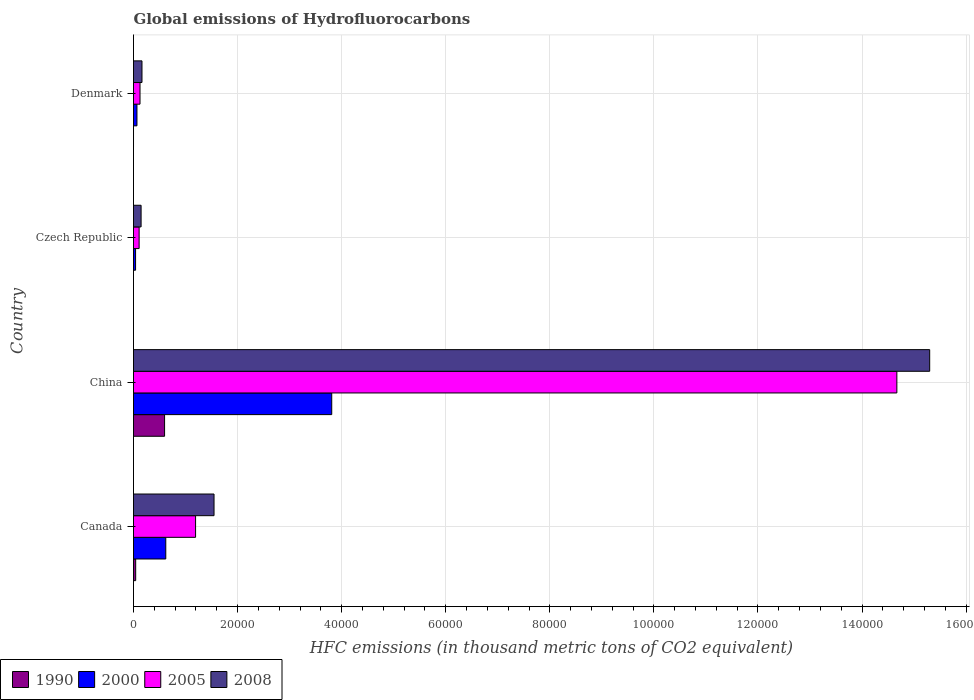How many groups of bars are there?
Offer a very short reply. 4. Are the number of bars on each tick of the Y-axis equal?
Offer a terse response. Yes. What is the global emissions of Hydrofluorocarbons in 2005 in China?
Keep it short and to the point. 1.47e+05. Across all countries, what is the maximum global emissions of Hydrofluorocarbons in 2008?
Make the answer very short. 1.53e+05. Across all countries, what is the minimum global emissions of Hydrofluorocarbons in 2000?
Give a very brief answer. 399.5. In which country was the global emissions of Hydrofluorocarbons in 2008 maximum?
Ensure brevity in your answer.  China. In which country was the global emissions of Hydrofluorocarbons in 2008 minimum?
Offer a very short reply. Czech Republic. What is the total global emissions of Hydrofluorocarbons in 2000 in the graph?
Provide a short and direct response. 4.54e+04. What is the difference between the global emissions of Hydrofluorocarbons in 1990 in Czech Republic and that in Denmark?
Provide a succinct answer. -0.2. What is the difference between the global emissions of Hydrofluorocarbons in 2005 in Denmark and the global emissions of Hydrofluorocarbons in 2000 in Canada?
Your response must be concise. -4953.3. What is the average global emissions of Hydrofluorocarbons in 2008 per country?
Keep it short and to the point. 4.29e+04. What is the difference between the global emissions of Hydrofluorocarbons in 2005 and global emissions of Hydrofluorocarbons in 2008 in China?
Your answer should be compact. -6309. In how many countries, is the global emissions of Hydrofluorocarbons in 2000 greater than 68000 thousand metric tons?
Your response must be concise. 0. What is the ratio of the global emissions of Hydrofluorocarbons in 2008 in China to that in Czech Republic?
Ensure brevity in your answer.  104.87. What is the difference between the highest and the second highest global emissions of Hydrofluorocarbons in 2005?
Offer a very short reply. 1.35e+05. What is the difference between the highest and the lowest global emissions of Hydrofluorocarbons in 1990?
Provide a succinct answer. 5970. Is the sum of the global emissions of Hydrofluorocarbons in 2005 in Czech Republic and Denmark greater than the maximum global emissions of Hydrofluorocarbons in 2008 across all countries?
Keep it short and to the point. No. Is it the case that in every country, the sum of the global emissions of Hydrofluorocarbons in 2000 and global emissions of Hydrofluorocarbons in 2008 is greater than the sum of global emissions of Hydrofluorocarbons in 1990 and global emissions of Hydrofluorocarbons in 2005?
Ensure brevity in your answer.  No. What does the 2nd bar from the top in China represents?
Your answer should be very brief. 2005. Are all the bars in the graph horizontal?
Offer a very short reply. Yes. What is the difference between two consecutive major ticks on the X-axis?
Give a very brief answer. 2.00e+04. Are the values on the major ticks of X-axis written in scientific E-notation?
Make the answer very short. No. Does the graph contain any zero values?
Keep it short and to the point. No. Where does the legend appear in the graph?
Offer a terse response. Bottom left. How are the legend labels stacked?
Offer a very short reply. Horizontal. What is the title of the graph?
Ensure brevity in your answer.  Global emissions of Hydrofluorocarbons. Does "1975" appear as one of the legend labels in the graph?
Keep it short and to the point. No. What is the label or title of the X-axis?
Your answer should be compact. HFC emissions (in thousand metric tons of CO2 equivalent). What is the label or title of the Y-axis?
Your response must be concise. Country. What is the HFC emissions (in thousand metric tons of CO2 equivalent) in 1990 in Canada?
Your answer should be very brief. 418.5. What is the HFC emissions (in thousand metric tons of CO2 equivalent) of 2000 in Canada?
Give a very brief answer. 6202.8. What is the HFC emissions (in thousand metric tons of CO2 equivalent) in 2005 in Canada?
Offer a terse response. 1.19e+04. What is the HFC emissions (in thousand metric tons of CO2 equivalent) in 2008 in Canada?
Offer a very short reply. 1.55e+04. What is the HFC emissions (in thousand metric tons of CO2 equivalent) of 1990 in China?
Give a very brief answer. 5970.1. What is the HFC emissions (in thousand metric tons of CO2 equivalent) in 2000 in China?
Make the answer very short. 3.81e+04. What is the HFC emissions (in thousand metric tons of CO2 equivalent) of 2005 in China?
Your response must be concise. 1.47e+05. What is the HFC emissions (in thousand metric tons of CO2 equivalent) in 2008 in China?
Make the answer very short. 1.53e+05. What is the HFC emissions (in thousand metric tons of CO2 equivalent) of 2000 in Czech Republic?
Provide a succinct answer. 399.5. What is the HFC emissions (in thousand metric tons of CO2 equivalent) in 2005 in Czech Republic?
Your answer should be very brief. 1078.7. What is the HFC emissions (in thousand metric tons of CO2 equivalent) in 2008 in Czech Republic?
Provide a short and direct response. 1459. What is the HFC emissions (in thousand metric tons of CO2 equivalent) of 2000 in Denmark?
Make the answer very short. 662.2. What is the HFC emissions (in thousand metric tons of CO2 equivalent) in 2005 in Denmark?
Provide a succinct answer. 1249.5. What is the HFC emissions (in thousand metric tons of CO2 equivalent) in 2008 in Denmark?
Give a very brief answer. 1629.6. Across all countries, what is the maximum HFC emissions (in thousand metric tons of CO2 equivalent) in 1990?
Offer a very short reply. 5970.1. Across all countries, what is the maximum HFC emissions (in thousand metric tons of CO2 equivalent) of 2000?
Provide a succinct answer. 3.81e+04. Across all countries, what is the maximum HFC emissions (in thousand metric tons of CO2 equivalent) in 2005?
Provide a succinct answer. 1.47e+05. Across all countries, what is the maximum HFC emissions (in thousand metric tons of CO2 equivalent) of 2008?
Provide a succinct answer. 1.53e+05. Across all countries, what is the minimum HFC emissions (in thousand metric tons of CO2 equivalent) in 1990?
Offer a very short reply. 0.1. Across all countries, what is the minimum HFC emissions (in thousand metric tons of CO2 equivalent) of 2000?
Keep it short and to the point. 399.5. Across all countries, what is the minimum HFC emissions (in thousand metric tons of CO2 equivalent) in 2005?
Give a very brief answer. 1078.7. Across all countries, what is the minimum HFC emissions (in thousand metric tons of CO2 equivalent) in 2008?
Offer a very short reply. 1459. What is the total HFC emissions (in thousand metric tons of CO2 equivalent) in 1990 in the graph?
Ensure brevity in your answer.  6389. What is the total HFC emissions (in thousand metric tons of CO2 equivalent) in 2000 in the graph?
Offer a terse response. 4.54e+04. What is the total HFC emissions (in thousand metric tons of CO2 equivalent) in 2005 in the graph?
Give a very brief answer. 1.61e+05. What is the total HFC emissions (in thousand metric tons of CO2 equivalent) of 2008 in the graph?
Offer a very short reply. 1.72e+05. What is the difference between the HFC emissions (in thousand metric tons of CO2 equivalent) of 1990 in Canada and that in China?
Provide a succinct answer. -5551.6. What is the difference between the HFC emissions (in thousand metric tons of CO2 equivalent) in 2000 in Canada and that in China?
Offer a terse response. -3.19e+04. What is the difference between the HFC emissions (in thousand metric tons of CO2 equivalent) of 2005 in Canada and that in China?
Give a very brief answer. -1.35e+05. What is the difference between the HFC emissions (in thousand metric tons of CO2 equivalent) in 2008 in Canada and that in China?
Your answer should be very brief. -1.38e+05. What is the difference between the HFC emissions (in thousand metric tons of CO2 equivalent) in 1990 in Canada and that in Czech Republic?
Your response must be concise. 418.4. What is the difference between the HFC emissions (in thousand metric tons of CO2 equivalent) of 2000 in Canada and that in Czech Republic?
Your answer should be compact. 5803.3. What is the difference between the HFC emissions (in thousand metric tons of CO2 equivalent) of 2005 in Canada and that in Czech Republic?
Offer a terse response. 1.08e+04. What is the difference between the HFC emissions (in thousand metric tons of CO2 equivalent) of 2008 in Canada and that in Czech Republic?
Your response must be concise. 1.40e+04. What is the difference between the HFC emissions (in thousand metric tons of CO2 equivalent) of 1990 in Canada and that in Denmark?
Keep it short and to the point. 418.2. What is the difference between the HFC emissions (in thousand metric tons of CO2 equivalent) of 2000 in Canada and that in Denmark?
Make the answer very short. 5540.6. What is the difference between the HFC emissions (in thousand metric tons of CO2 equivalent) of 2005 in Canada and that in Denmark?
Ensure brevity in your answer.  1.07e+04. What is the difference between the HFC emissions (in thousand metric tons of CO2 equivalent) in 2008 in Canada and that in Denmark?
Give a very brief answer. 1.38e+04. What is the difference between the HFC emissions (in thousand metric tons of CO2 equivalent) of 1990 in China and that in Czech Republic?
Make the answer very short. 5970. What is the difference between the HFC emissions (in thousand metric tons of CO2 equivalent) of 2000 in China and that in Czech Republic?
Your answer should be very brief. 3.77e+04. What is the difference between the HFC emissions (in thousand metric tons of CO2 equivalent) of 2005 in China and that in Czech Republic?
Your response must be concise. 1.46e+05. What is the difference between the HFC emissions (in thousand metric tons of CO2 equivalent) of 2008 in China and that in Czech Republic?
Keep it short and to the point. 1.52e+05. What is the difference between the HFC emissions (in thousand metric tons of CO2 equivalent) of 1990 in China and that in Denmark?
Give a very brief answer. 5969.8. What is the difference between the HFC emissions (in thousand metric tons of CO2 equivalent) of 2000 in China and that in Denmark?
Keep it short and to the point. 3.74e+04. What is the difference between the HFC emissions (in thousand metric tons of CO2 equivalent) of 2005 in China and that in Denmark?
Ensure brevity in your answer.  1.45e+05. What is the difference between the HFC emissions (in thousand metric tons of CO2 equivalent) in 2008 in China and that in Denmark?
Your response must be concise. 1.51e+05. What is the difference between the HFC emissions (in thousand metric tons of CO2 equivalent) of 1990 in Czech Republic and that in Denmark?
Your answer should be compact. -0.2. What is the difference between the HFC emissions (in thousand metric tons of CO2 equivalent) in 2000 in Czech Republic and that in Denmark?
Your answer should be very brief. -262.7. What is the difference between the HFC emissions (in thousand metric tons of CO2 equivalent) in 2005 in Czech Republic and that in Denmark?
Give a very brief answer. -170.8. What is the difference between the HFC emissions (in thousand metric tons of CO2 equivalent) in 2008 in Czech Republic and that in Denmark?
Your answer should be very brief. -170.6. What is the difference between the HFC emissions (in thousand metric tons of CO2 equivalent) of 1990 in Canada and the HFC emissions (in thousand metric tons of CO2 equivalent) of 2000 in China?
Make the answer very short. -3.77e+04. What is the difference between the HFC emissions (in thousand metric tons of CO2 equivalent) in 1990 in Canada and the HFC emissions (in thousand metric tons of CO2 equivalent) in 2005 in China?
Your answer should be very brief. -1.46e+05. What is the difference between the HFC emissions (in thousand metric tons of CO2 equivalent) of 1990 in Canada and the HFC emissions (in thousand metric tons of CO2 equivalent) of 2008 in China?
Provide a succinct answer. -1.53e+05. What is the difference between the HFC emissions (in thousand metric tons of CO2 equivalent) in 2000 in Canada and the HFC emissions (in thousand metric tons of CO2 equivalent) in 2005 in China?
Your response must be concise. -1.40e+05. What is the difference between the HFC emissions (in thousand metric tons of CO2 equivalent) in 2000 in Canada and the HFC emissions (in thousand metric tons of CO2 equivalent) in 2008 in China?
Ensure brevity in your answer.  -1.47e+05. What is the difference between the HFC emissions (in thousand metric tons of CO2 equivalent) of 2005 in Canada and the HFC emissions (in thousand metric tons of CO2 equivalent) of 2008 in China?
Provide a short and direct response. -1.41e+05. What is the difference between the HFC emissions (in thousand metric tons of CO2 equivalent) of 1990 in Canada and the HFC emissions (in thousand metric tons of CO2 equivalent) of 2005 in Czech Republic?
Make the answer very short. -660.2. What is the difference between the HFC emissions (in thousand metric tons of CO2 equivalent) in 1990 in Canada and the HFC emissions (in thousand metric tons of CO2 equivalent) in 2008 in Czech Republic?
Provide a short and direct response. -1040.5. What is the difference between the HFC emissions (in thousand metric tons of CO2 equivalent) of 2000 in Canada and the HFC emissions (in thousand metric tons of CO2 equivalent) of 2005 in Czech Republic?
Your answer should be compact. 5124.1. What is the difference between the HFC emissions (in thousand metric tons of CO2 equivalent) of 2000 in Canada and the HFC emissions (in thousand metric tons of CO2 equivalent) of 2008 in Czech Republic?
Ensure brevity in your answer.  4743.8. What is the difference between the HFC emissions (in thousand metric tons of CO2 equivalent) in 2005 in Canada and the HFC emissions (in thousand metric tons of CO2 equivalent) in 2008 in Czech Republic?
Provide a succinct answer. 1.05e+04. What is the difference between the HFC emissions (in thousand metric tons of CO2 equivalent) in 1990 in Canada and the HFC emissions (in thousand metric tons of CO2 equivalent) in 2000 in Denmark?
Provide a short and direct response. -243.7. What is the difference between the HFC emissions (in thousand metric tons of CO2 equivalent) of 1990 in Canada and the HFC emissions (in thousand metric tons of CO2 equivalent) of 2005 in Denmark?
Your answer should be very brief. -831. What is the difference between the HFC emissions (in thousand metric tons of CO2 equivalent) of 1990 in Canada and the HFC emissions (in thousand metric tons of CO2 equivalent) of 2008 in Denmark?
Your answer should be compact. -1211.1. What is the difference between the HFC emissions (in thousand metric tons of CO2 equivalent) of 2000 in Canada and the HFC emissions (in thousand metric tons of CO2 equivalent) of 2005 in Denmark?
Your answer should be very brief. 4953.3. What is the difference between the HFC emissions (in thousand metric tons of CO2 equivalent) in 2000 in Canada and the HFC emissions (in thousand metric tons of CO2 equivalent) in 2008 in Denmark?
Provide a succinct answer. 4573.2. What is the difference between the HFC emissions (in thousand metric tons of CO2 equivalent) of 2005 in Canada and the HFC emissions (in thousand metric tons of CO2 equivalent) of 2008 in Denmark?
Offer a very short reply. 1.03e+04. What is the difference between the HFC emissions (in thousand metric tons of CO2 equivalent) of 1990 in China and the HFC emissions (in thousand metric tons of CO2 equivalent) of 2000 in Czech Republic?
Offer a very short reply. 5570.6. What is the difference between the HFC emissions (in thousand metric tons of CO2 equivalent) in 1990 in China and the HFC emissions (in thousand metric tons of CO2 equivalent) in 2005 in Czech Republic?
Make the answer very short. 4891.4. What is the difference between the HFC emissions (in thousand metric tons of CO2 equivalent) of 1990 in China and the HFC emissions (in thousand metric tons of CO2 equivalent) of 2008 in Czech Republic?
Offer a very short reply. 4511.1. What is the difference between the HFC emissions (in thousand metric tons of CO2 equivalent) of 2000 in China and the HFC emissions (in thousand metric tons of CO2 equivalent) of 2005 in Czech Republic?
Ensure brevity in your answer.  3.70e+04. What is the difference between the HFC emissions (in thousand metric tons of CO2 equivalent) in 2000 in China and the HFC emissions (in thousand metric tons of CO2 equivalent) in 2008 in Czech Republic?
Offer a terse response. 3.66e+04. What is the difference between the HFC emissions (in thousand metric tons of CO2 equivalent) in 2005 in China and the HFC emissions (in thousand metric tons of CO2 equivalent) in 2008 in Czech Republic?
Provide a succinct answer. 1.45e+05. What is the difference between the HFC emissions (in thousand metric tons of CO2 equivalent) in 1990 in China and the HFC emissions (in thousand metric tons of CO2 equivalent) in 2000 in Denmark?
Make the answer very short. 5307.9. What is the difference between the HFC emissions (in thousand metric tons of CO2 equivalent) in 1990 in China and the HFC emissions (in thousand metric tons of CO2 equivalent) in 2005 in Denmark?
Provide a short and direct response. 4720.6. What is the difference between the HFC emissions (in thousand metric tons of CO2 equivalent) in 1990 in China and the HFC emissions (in thousand metric tons of CO2 equivalent) in 2008 in Denmark?
Offer a terse response. 4340.5. What is the difference between the HFC emissions (in thousand metric tons of CO2 equivalent) of 2000 in China and the HFC emissions (in thousand metric tons of CO2 equivalent) of 2005 in Denmark?
Offer a terse response. 3.68e+04. What is the difference between the HFC emissions (in thousand metric tons of CO2 equivalent) of 2000 in China and the HFC emissions (in thousand metric tons of CO2 equivalent) of 2008 in Denmark?
Make the answer very short. 3.65e+04. What is the difference between the HFC emissions (in thousand metric tons of CO2 equivalent) in 2005 in China and the HFC emissions (in thousand metric tons of CO2 equivalent) in 2008 in Denmark?
Provide a short and direct response. 1.45e+05. What is the difference between the HFC emissions (in thousand metric tons of CO2 equivalent) of 1990 in Czech Republic and the HFC emissions (in thousand metric tons of CO2 equivalent) of 2000 in Denmark?
Offer a terse response. -662.1. What is the difference between the HFC emissions (in thousand metric tons of CO2 equivalent) of 1990 in Czech Republic and the HFC emissions (in thousand metric tons of CO2 equivalent) of 2005 in Denmark?
Provide a succinct answer. -1249.4. What is the difference between the HFC emissions (in thousand metric tons of CO2 equivalent) in 1990 in Czech Republic and the HFC emissions (in thousand metric tons of CO2 equivalent) in 2008 in Denmark?
Offer a very short reply. -1629.5. What is the difference between the HFC emissions (in thousand metric tons of CO2 equivalent) in 2000 in Czech Republic and the HFC emissions (in thousand metric tons of CO2 equivalent) in 2005 in Denmark?
Keep it short and to the point. -850. What is the difference between the HFC emissions (in thousand metric tons of CO2 equivalent) in 2000 in Czech Republic and the HFC emissions (in thousand metric tons of CO2 equivalent) in 2008 in Denmark?
Give a very brief answer. -1230.1. What is the difference between the HFC emissions (in thousand metric tons of CO2 equivalent) in 2005 in Czech Republic and the HFC emissions (in thousand metric tons of CO2 equivalent) in 2008 in Denmark?
Give a very brief answer. -550.9. What is the average HFC emissions (in thousand metric tons of CO2 equivalent) of 1990 per country?
Your response must be concise. 1597.25. What is the average HFC emissions (in thousand metric tons of CO2 equivalent) in 2000 per country?
Ensure brevity in your answer.  1.13e+04. What is the average HFC emissions (in thousand metric tons of CO2 equivalent) in 2005 per country?
Your answer should be compact. 4.02e+04. What is the average HFC emissions (in thousand metric tons of CO2 equivalent) in 2008 per country?
Give a very brief answer. 4.29e+04. What is the difference between the HFC emissions (in thousand metric tons of CO2 equivalent) in 1990 and HFC emissions (in thousand metric tons of CO2 equivalent) in 2000 in Canada?
Ensure brevity in your answer.  -5784.3. What is the difference between the HFC emissions (in thousand metric tons of CO2 equivalent) of 1990 and HFC emissions (in thousand metric tons of CO2 equivalent) of 2005 in Canada?
Offer a terse response. -1.15e+04. What is the difference between the HFC emissions (in thousand metric tons of CO2 equivalent) of 1990 and HFC emissions (in thousand metric tons of CO2 equivalent) of 2008 in Canada?
Ensure brevity in your answer.  -1.51e+04. What is the difference between the HFC emissions (in thousand metric tons of CO2 equivalent) of 2000 and HFC emissions (in thousand metric tons of CO2 equivalent) of 2005 in Canada?
Offer a very short reply. -5725.6. What is the difference between the HFC emissions (in thousand metric tons of CO2 equivalent) in 2000 and HFC emissions (in thousand metric tons of CO2 equivalent) in 2008 in Canada?
Provide a short and direct response. -9272. What is the difference between the HFC emissions (in thousand metric tons of CO2 equivalent) of 2005 and HFC emissions (in thousand metric tons of CO2 equivalent) of 2008 in Canada?
Your answer should be compact. -3546.4. What is the difference between the HFC emissions (in thousand metric tons of CO2 equivalent) in 1990 and HFC emissions (in thousand metric tons of CO2 equivalent) in 2000 in China?
Provide a short and direct response. -3.21e+04. What is the difference between the HFC emissions (in thousand metric tons of CO2 equivalent) of 1990 and HFC emissions (in thousand metric tons of CO2 equivalent) of 2005 in China?
Provide a succinct answer. -1.41e+05. What is the difference between the HFC emissions (in thousand metric tons of CO2 equivalent) of 1990 and HFC emissions (in thousand metric tons of CO2 equivalent) of 2008 in China?
Ensure brevity in your answer.  -1.47e+05. What is the difference between the HFC emissions (in thousand metric tons of CO2 equivalent) in 2000 and HFC emissions (in thousand metric tons of CO2 equivalent) in 2005 in China?
Your answer should be compact. -1.09e+05. What is the difference between the HFC emissions (in thousand metric tons of CO2 equivalent) of 2000 and HFC emissions (in thousand metric tons of CO2 equivalent) of 2008 in China?
Ensure brevity in your answer.  -1.15e+05. What is the difference between the HFC emissions (in thousand metric tons of CO2 equivalent) of 2005 and HFC emissions (in thousand metric tons of CO2 equivalent) of 2008 in China?
Provide a succinct answer. -6309. What is the difference between the HFC emissions (in thousand metric tons of CO2 equivalent) of 1990 and HFC emissions (in thousand metric tons of CO2 equivalent) of 2000 in Czech Republic?
Ensure brevity in your answer.  -399.4. What is the difference between the HFC emissions (in thousand metric tons of CO2 equivalent) of 1990 and HFC emissions (in thousand metric tons of CO2 equivalent) of 2005 in Czech Republic?
Ensure brevity in your answer.  -1078.6. What is the difference between the HFC emissions (in thousand metric tons of CO2 equivalent) of 1990 and HFC emissions (in thousand metric tons of CO2 equivalent) of 2008 in Czech Republic?
Provide a short and direct response. -1458.9. What is the difference between the HFC emissions (in thousand metric tons of CO2 equivalent) in 2000 and HFC emissions (in thousand metric tons of CO2 equivalent) in 2005 in Czech Republic?
Keep it short and to the point. -679.2. What is the difference between the HFC emissions (in thousand metric tons of CO2 equivalent) in 2000 and HFC emissions (in thousand metric tons of CO2 equivalent) in 2008 in Czech Republic?
Offer a very short reply. -1059.5. What is the difference between the HFC emissions (in thousand metric tons of CO2 equivalent) in 2005 and HFC emissions (in thousand metric tons of CO2 equivalent) in 2008 in Czech Republic?
Your answer should be compact. -380.3. What is the difference between the HFC emissions (in thousand metric tons of CO2 equivalent) of 1990 and HFC emissions (in thousand metric tons of CO2 equivalent) of 2000 in Denmark?
Make the answer very short. -661.9. What is the difference between the HFC emissions (in thousand metric tons of CO2 equivalent) in 1990 and HFC emissions (in thousand metric tons of CO2 equivalent) in 2005 in Denmark?
Make the answer very short. -1249.2. What is the difference between the HFC emissions (in thousand metric tons of CO2 equivalent) in 1990 and HFC emissions (in thousand metric tons of CO2 equivalent) in 2008 in Denmark?
Offer a very short reply. -1629.3. What is the difference between the HFC emissions (in thousand metric tons of CO2 equivalent) of 2000 and HFC emissions (in thousand metric tons of CO2 equivalent) of 2005 in Denmark?
Offer a very short reply. -587.3. What is the difference between the HFC emissions (in thousand metric tons of CO2 equivalent) of 2000 and HFC emissions (in thousand metric tons of CO2 equivalent) of 2008 in Denmark?
Give a very brief answer. -967.4. What is the difference between the HFC emissions (in thousand metric tons of CO2 equivalent) in 2005 and HFC emissions (in thousand metric tons of CO2 equivalent) in 2008 in Denmark?
Your answer should be very brief. -380.1. What is the ratio of the HFC emissions (in thousand metric tons of CO2 equivalent) of 1990 in Canada to that in China?
Your response must be concise. 0.07. What is the ratio of the HFC emissions (in thousand metric tons of CO2 equivalent) of 2000 in Canada to that in China?
Your answer should be very brief. 0.16. What is the ratio of the HFC emissions (in thousand metric tons of CO2 equivalent) in 2005 in Canada to that in China?
Ensure brevity in your answer.  0.08. What is the ratio of the HFC emissions (in thousand metric tons of CO2 equivalent) in 2008 in Canada to that in China?
Make the answer very short. 0.1. What is the ratio of the HFC emissions (in thousand metric tons of CO2 equivalent) of 1990 in Canada to that in Czech Republic?
Offer a terse response. 4185. What is the ratio of the HFC emissions (in thousand metric tons of CO2 equivalent) in 2000 in Canada to that in Czech Republic?
Keep it short and to the point. 15.53. What is the ratio of the HFC emissions (in thousand metric tons of CO2 equivalent) in 2005 in Canada to that in Czech Republic?
Ensure brevity in your answer.  11.06. What is the ratio of the HFC emissions (in thousand metric tons of CO2 equivalent) of 2008 in Canada to that in Czech Republic?
Offer a terse response. 10.61. What is the ratio of the HFC emissions (in thousand metric tons of CO2 equivalent) in 1990 in Canada to that in Denmark?
Keep it short and to the point. 1395. What is the ratio of the HFC emissions (in thousand metric tons of CO2 equivalent) in 2000 in Canada to that in Denmark?
Offer a very short reply. 9.37. What is the ratio of the HFC emissions (in thousand metric tons of CO2 equivalent) in 2005 in Canada to that in Denmark?
Ensure brevity in your answer.  9.55. What is the ratio of the HFC emissions (in thousand metric tons of CO2 equivalent) in 2008 in Canada to that in Denmark?
Your answer should be very brief. 9.5. What is the ratio of the HFC emissions (in thousand metric tons of CO2 equivalent) in 1990 in China to that in Czech Republic?
Offer a very short reply. 5.97e+04. What is the ratio of the HFC emissions (in thousand metric tons of CO2 equivalent) of 2000 in China to that in Czech Republic?
Provide a short and direct response. 95.35. What is the ratio of the HFC emissions (in thousand metric tons of CO2 equivalent) of 2005 in China to that in Czech Republic?
Ensure brevity in your answer.  135.99. What is the ratio of the HFC emissions (in thousand metric tons of CO2 equivalent) in 2008 in China to that in Czech Republic?
Give a very brief answer. 104.87. What is the ratio of the HFC emissions (in thousand metric tons of CO2 equivalent) in 1990 in China to that in Denmark?
Your answer should be very brief. 1.99e+04. What is the ratio of the HFC emissions (in thousand metric tons of CO2 equivalent) in 2000 in China to that in Denmark?
Make the answer very short. 57.53. What is the ratio of the HFC emissions (in thousand metric tons of CO2 equivalent) in 2005 in China to that in Denmark?
Give a very brief answer. 117.4. What is the ratio of the HFC emissions (in thousand metric tons of CO2 equivalent) in 2008 in China to that in Denmark?
Make the answer very short. 93.89. What is the ratio of the HFC emissions (in thousand metric tons of CO2 equivalent) of 1990 in Czech Republic to that in Denmark?
Offer a terse response. 0.33. What is the ratio of the HFC emissions (in thousand metric tons of CO2 equivalent) in 2000 in Czech Republic to that in Denmark?
Your response must be concise. 0.6. What is the ratio of the HFC emissions (in thousand metric tons of CO2 equivalent) in 2005 in Czech Republic to that in Denmark?
Give a very brief answer. 0.86. What is the ratio of the HFC emissions (in thousand metric tons of CO2 equivalent) of 2008 in Czech Republic to that in Denmark?
Offer a very short reply. 0.9. What is the difference between the highest and the second highest HFC emissions (in thousand metric tons of CO2 equivalent) of 1990?
Provide a short and direct response. 5551.6. What is the difference between the highest and the second highest HFC emissions (in thousand metric tons of CO2 equivalent) in 2000?
Make the answer very short. 3.19e+04. What is the difference between the highest and the second highest HFC emissions (in thousand metric tons of CO2 equivalent) of 2005?
Ensure brevity in your answer.  1.35e+05. What is the difference between the highest and the second highest HFC emissions (in thousand metric tons of CO2 equivalent) of 2008?
Offer a terse response. 1.38e+05. What is the difference between the highest and the lowest HFC emissions (in thousand metric tons of CO2 equivalent) of 1990?
Make the answer very short. 5970. What is the difference between the highest and the lowest HFC emissions (in thousand metric tons of CO2 equivalent) in 2000?
Provide a succinct answer. 3.77e+04. What is the difference between the highest and the lowest HFC emissions (in thousand metric tons of CO2 equivalent) of 2005?
Offer a terse response. 1.46e+05. What is the difference between the highest and the lowest HFC emissions (in thousand metric tons of CO2 equivalent) of 2008?
Keep it short and to the point. 1.52e+05. 